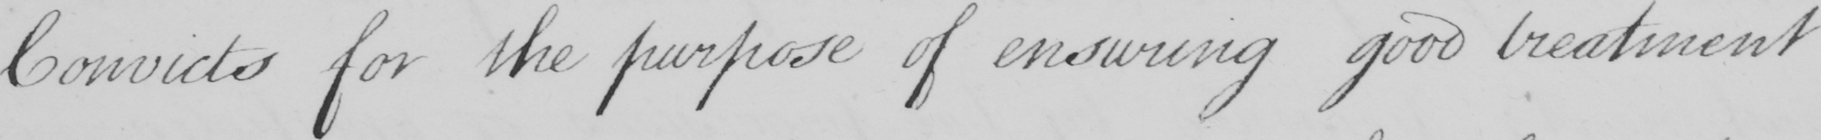What does this handwritten line say? Convicts for the purpose of ensuring good treatment 